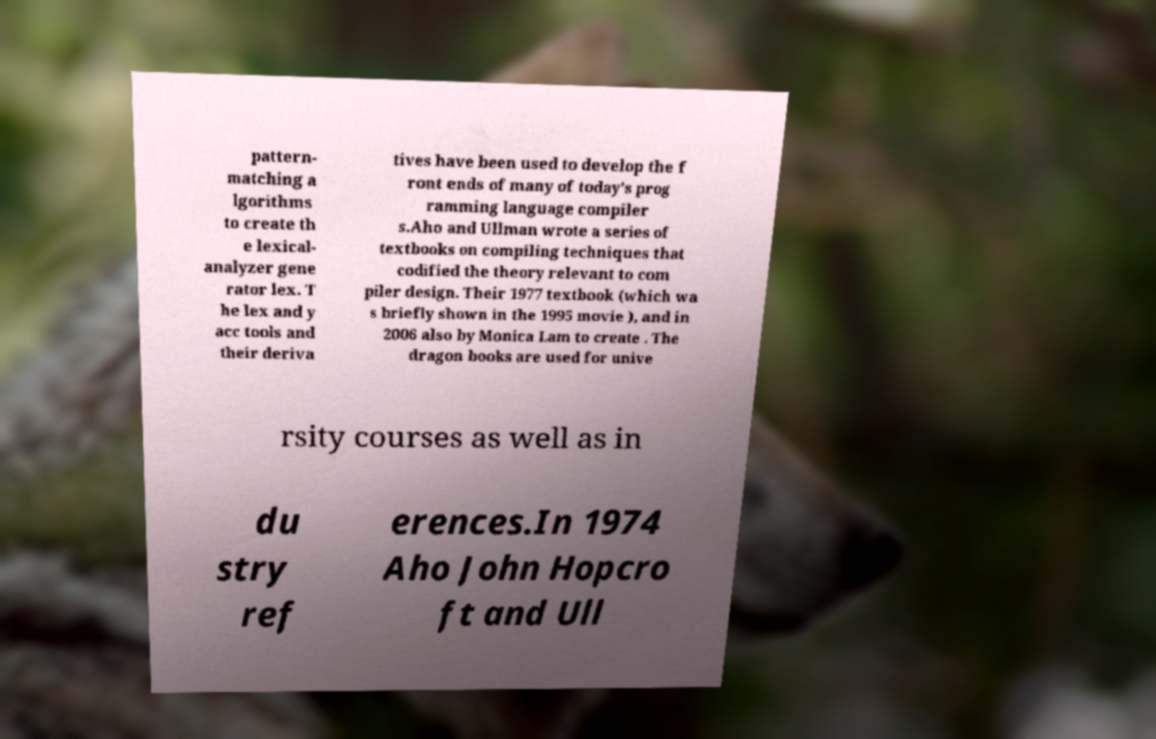Could you extract and type out the text from this image? pattern- matching a lgorithms to create th e lexical- analyzer gene rator lex. T he lex and y acc tools and their deriva tives have been used to develop the f ront ends of many of today's prog ramming language compiler s.Aho and Ullman wrote a series of textbooks on compiling techniques that codified the theory relevant to com piler design. Their 1977 textbook (which wa s briefly shown in the 1995 movie ), and in 2006 also by Monica Lam to create . The dragon books are used for unive rsity courses as well as in du stry ref erences.In 1974 Aho John Hopcro ft and Ull 